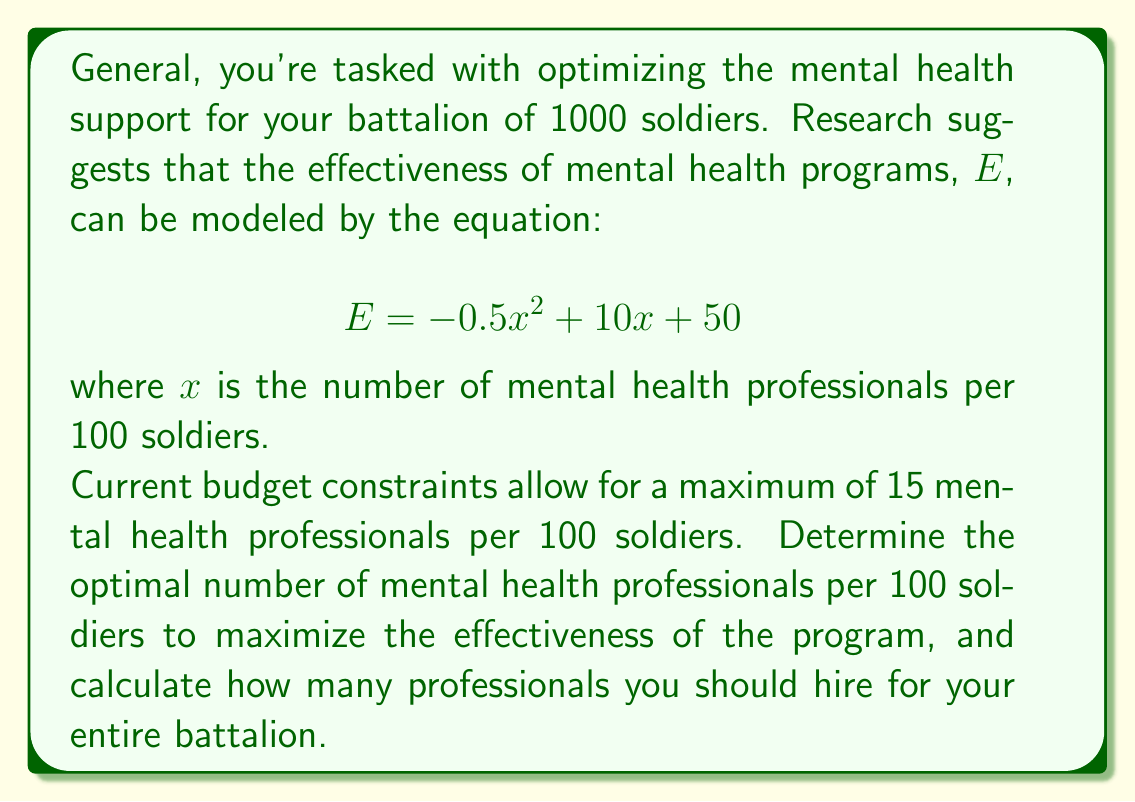Solve this math problem. To solve this problem, we need to follow these steps:

1) First, we need to find the maximum of the quadratic function $E = -0.5x^2 + 10x + 50$. 

2) To find the maximum, we can use the vertex formula for a quadratic function in the form $ax^2 + bx + c$:

   $$x = -\frac{b}{2a}$$

3) In our case, $a = -0.5$ and $b = 10$. Let's substitute these values:

   $$x = -\frac{10}{2(-0.5)} = \frac{10}{1} = 10$$

4) This means the optimal number of mental health professionals per 100 soldiers is 10.

5) We need to check if this is within our constraint of a maximum of 15 professionals per 100 soldiers. Since 10 < 15, our solution satisfies the constraint.

6) Now, to find the number of professionals for the entire battalion of 1000 soldiers, we set up a proportion:

   $$\frac{10\text{ professionals}}{100\text{ soldiers}} = \frac{x\text{ professionals}}{1000\text{ soldiers}}$$

7) Cross multiply and solve for x:

   $$100x = 10 * 1000$$
   $$x = \frac{10000}{100} = 100$$

Therefore, for the entire battalion of 1000 soldiers, you should hire 100 mental health professionals.
Answer: The optimal ratio is 10 mental health professionals per 100 soldiers. For a battalion of 1000 soldiers, hire 100 mental health professionals. 